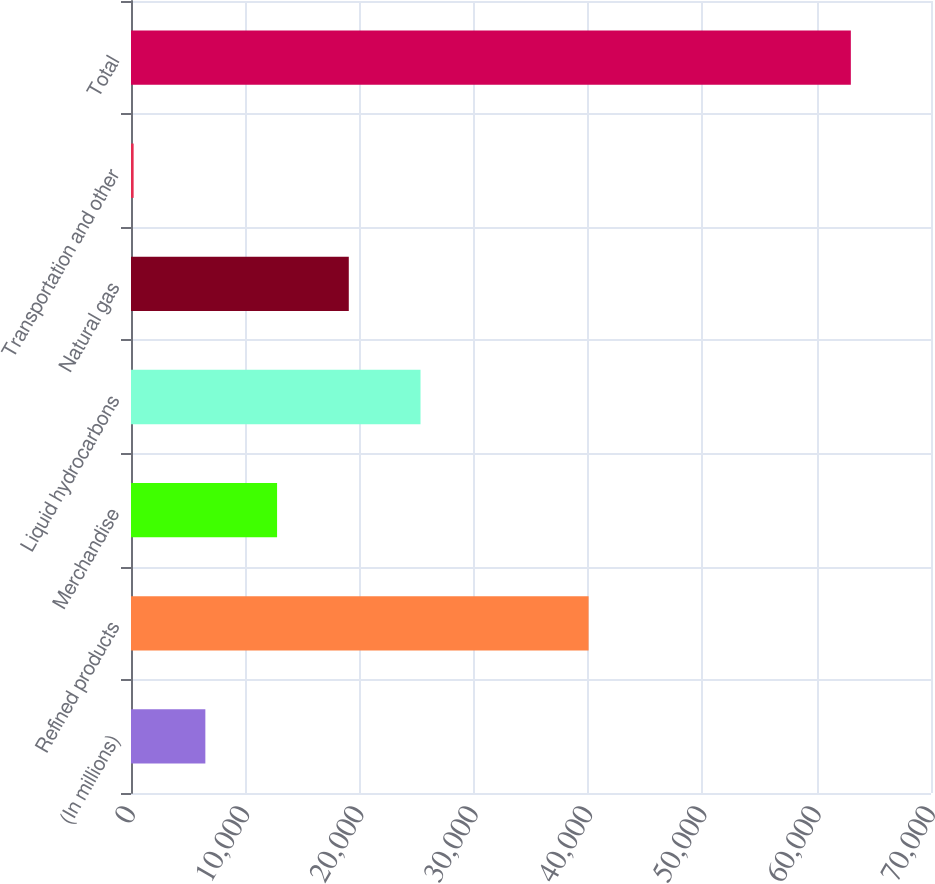Convert chart to OTSL. <chart><loc_0><loc_0><loc_500><loc_500><bar_chart><fcel>(In millions)<fcel>Refined products<fcel>Merchandise<fcel>Liquid hydrocarbons<fcel>Natural gas<fcel>Transportation and other<fcel>Total<nl><fcel>6505.6<fcel>40040<fcel>12781.2<fcel>25332.4<fcel>19056.8<fcel>230<fcel>62986<nl></chart> 